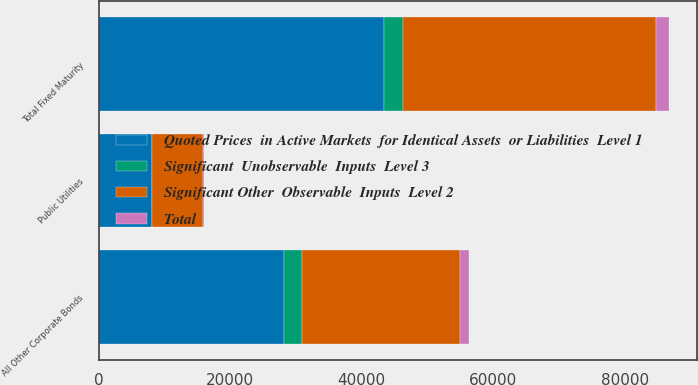Convert chart to OTSL. <chart><loc_0><loc_0><loc_500><loc_500><stacked_bar_chart><ecel><fcel>Public Utilities<fcel>All Other Corporate Bonds<fcel>Total Fixed Maturity<nl><fcel>Significant  Unobservable  Inputs  Level 3<fcel>59.1<fcel>2770.4<fcel>2926.8<nl><fcel>Significant Other  Observable  Inputs  Level 2<fcel>7687.2<fcel>23992.8<fcel>38546.4<nl><fcel>Total<fcel>274.1<fcel>1408.2<fcel>1881.2<nl><fcel>Quoted Prices  in Active Markets  for Identical Assets  or Liabilities  Level 1<fcel>8020.4<fcel>28171.4<fcel>43354.4<nl></chart> 